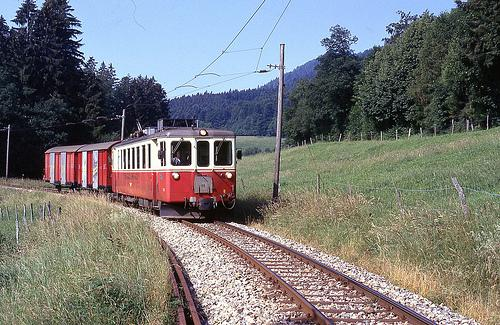How many windshield wipers are on the train's front glass, and what is one other feature on the front of the train? There is one wiper on the front glass, with three head lights that are turned on. What kind of fence is present in the image, and where is it located in relation to the trees? A wire and wood fence is present, located in front of the tall trees. What is surrounding and/or intersecting the train tracks? There is a stone path on the train tracks, with rocks and white rocks around them, and grass near the train tracks. Mention two types of flora present in the image and their respective colors. Tall green grass and dead brown grass are present in the image. What type of vehicle is predominantly featured in this image and mention its color? A red and white train is predominantly featured in the image. What are the objects placed on the ground near the train tracks, and describe their appearance? There are stakes in the ground, looking like wooden or metal items. How many windows can be seen on the right side of the train, and what color is the door on the train? There are two windows on the right side of the train, and the door is red and white. Based on the image, identify an action performed by the train or mention the state of the train. The short train is stationary on the tracks amidst a forest setting. State one action happening within the train and describe something located above the train. The train conductor can be seen through a window, and there are electrical wires above the train held by poles. Describe the terrain where the train is located, and mention any distinct features. The train is located on a train track in a forest, with rocks, grass, trees, and a fence near the train tracks. Is there a river flowing next to the train track? No, it's not mentioned in the image. Is there a blue and orange train in the image? There is no blue and orange train mentioned in the list; only red and white trains are described. Can you find a giraffe standing near the train tracks? There is no mention of a giraffe or any non-landscape element other than the train and its tracks. 